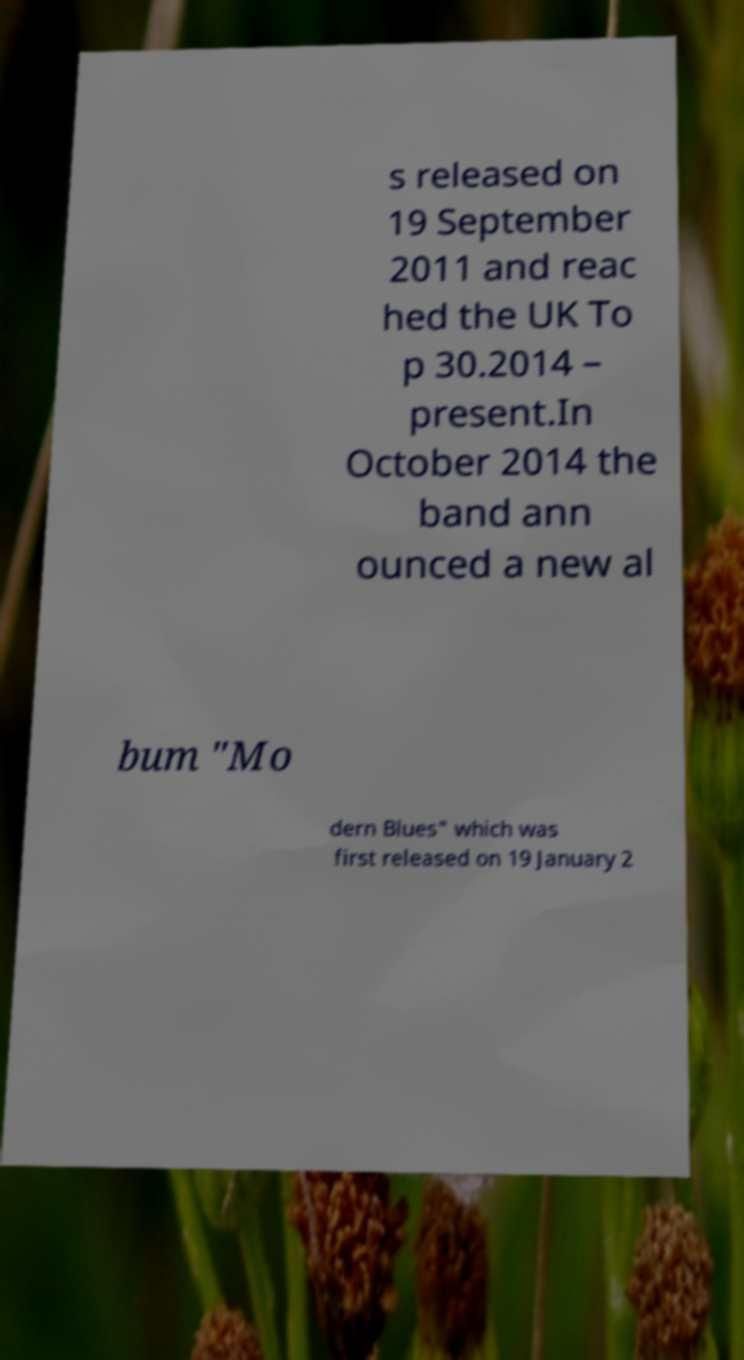Can you accurately transcribe the text from the provided image for me? s released on 19 September 2011 and reac hed the UK To p 30.2014 – present.In October 2014 the band ann ounced a new al bum "Mo dern Blues" which was first released on 19 January 2 